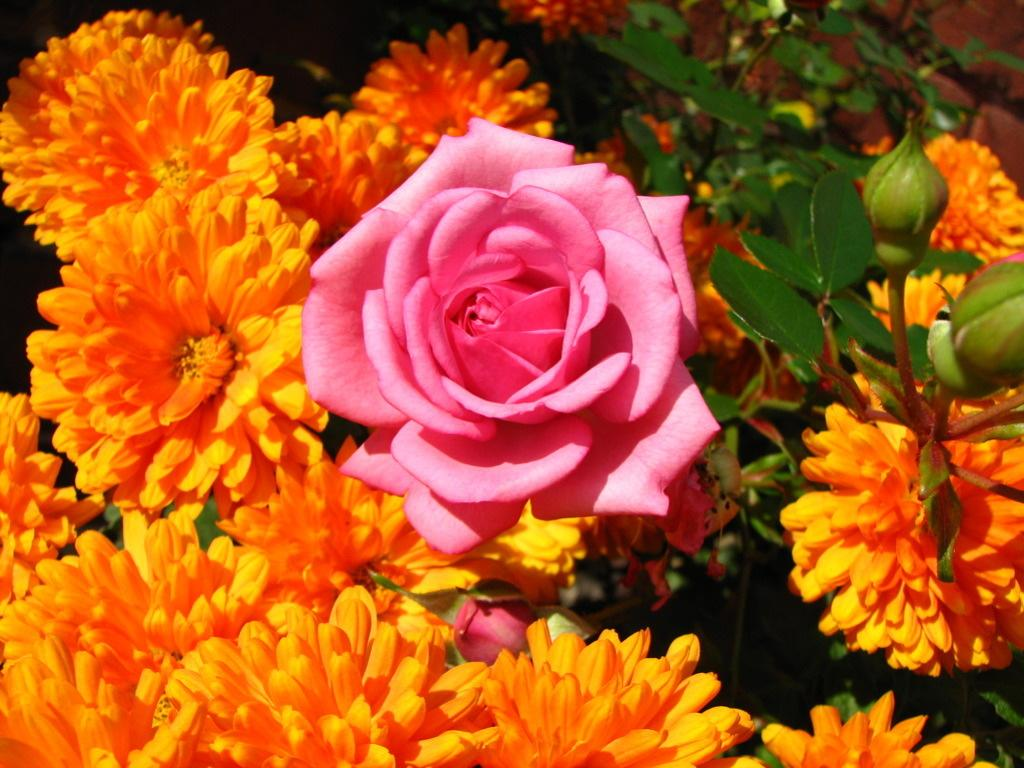What type of plant life is present in the image? There are flowers, leaves, and buds in the image. Can you describe the different stages of growth depicted in the image? The image shows flowers, leaves, and buds, which represent different stages of plant growth. Are there any other elements in the image besides plant life? The provided facts do not mention any other elements in the image. How many cubs can be seen playing in the water in the image? There are no cubs or water present in the image; it features flowers, leaves, and buds. 